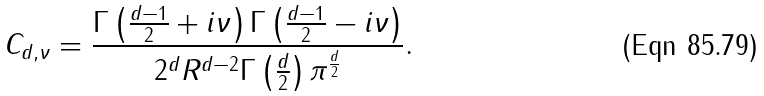Convert formula to latex. <formula><loc_0><loc_0><loc_500><loc_500>C _ { d , \nu } = \frac { \Gamma \left ( \frac { d - 1 } { 2 } + i \nu \right ) \Gamma \left ( \frac { d - 1 } { 2 } - i \nu \right ) } { 2 ^ { d } R ^ { d - 2 } \Gamma \left ( \frac { d } { 2 } \right ) \pi ^ { \frac { d } { 2 } } } .</formula> 